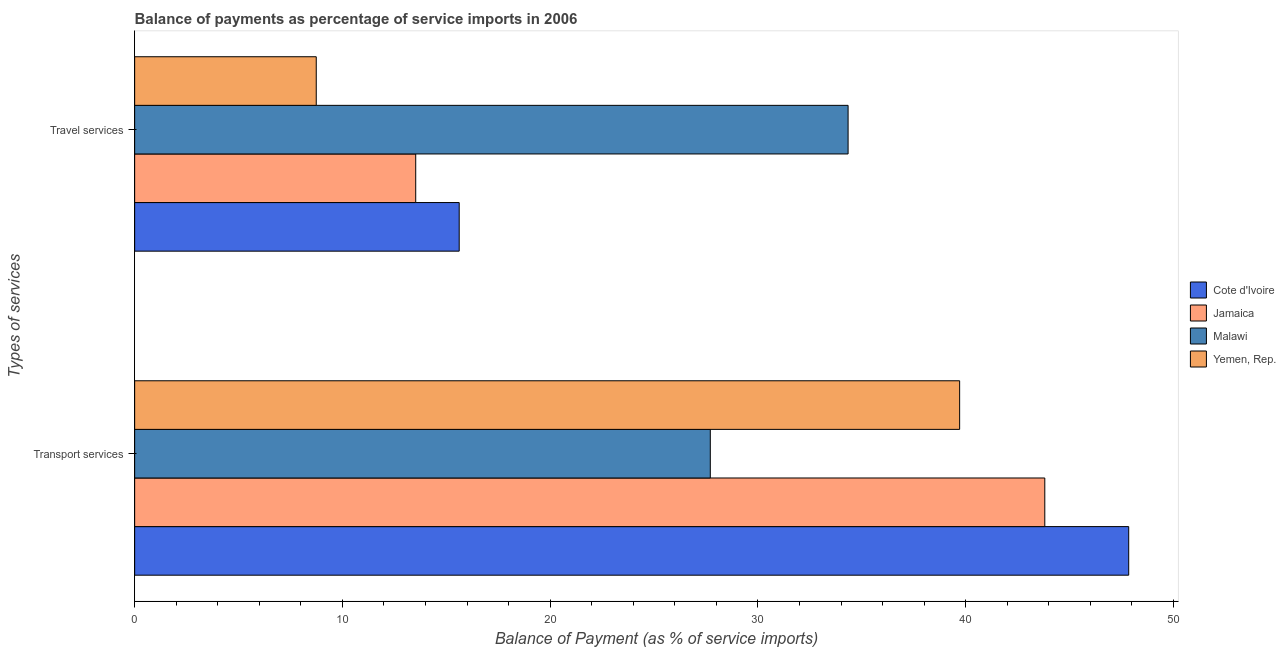How many different coloured bars are there?
Ensure brevity in your answer.  4. Are the number of bars per tick equal to the number of legend labels?
Provide a short and direct response. Yes. Are the number of bars on each tick of the Y-axis equal?
Offer a very short reply. Yes. What is the label of the 1st group of bars from the top?
Your answer should be very brief. Travel services. What is the balance of payments of travel services in Cote d'Ivoire?
Offer a very short reply. 15.62. Across all countries, what is the maximum balance of payments of transport services?
Provide a succinct answer. 47.85. Across all countries, what is the minimum balance of payments of travel services?
Give a very brief answer. 8.74. In which country was the balance of payments of transport services maximum?
Offer a very short reply. Cote d'Ivoire. In which country was the balance of payments of transport services minimum?
Offer a terse response. Malawi. What is the total balance of payments of transport services in the graph?
Offer a terse response. 159.07. What is the difference between the balance of payments of travel services in Cote d'Ivoire and that in Malawi?
Your response must be concise. -18.72. What is the difference between the balance of payments of travel services in Yemen, Rep. and the balance of payments of transport services in Malawi?
Offer a terse response. -18.97. What is the average balance of payments of transport services per country?
Make the answer very short. 39.77. What is the difference between the balance of payments of travel services and balance of payments of transport services in Yemen, Rep.?
Your response must be concise. -30.97. What is the ratio of the balance of payments of travel services in Malawi to that in Cote d'Ivoire?
Give a very brief answer. 2.2. Is the balance of payments of transport services in Cote d'Ivoire less than that in Yemen, Rep.?
Give a very brief answer. No. What does the 2nd bar from the top in Transport services represents?
Keep it short and to the point. Malawi. What does the 1st bar from the bottom in Transport services represents?
Offer a very short reply. Cote d'Ivoire. Are all the bars in the graph horizontal?
Offer a very short reply. Yes. What is the difference between two consecutive major ticks on the X-axis?
Your answer should be compact. 10. Are the values on the major ticks of X-axis written in scientific E-notation?
Offer a terse response. No. Does the graph contain grids?
Offer a terse response. No. Where does the legend appear in the graph?
Keep it short and to the point. Center right. How many legend labels are there?
Your answer should be compact. 4. How are the legend labels stacked?
Provide a short and direct response. Vertical. What is the title of the graph?
Make the answer very short. Balance of payments as percentage of service imports in 2006. Does "Belize" appear as one of the legend labels in the graph?
Give a very brief answer. No. What is the label or title of the X-axis?
Provide a succinct answer. Balance of Payment (as % of service imports). What is the label or title of the Y-axis?
Provide a succinct answer. Types of services. What is the Balance of Payment (as % of service imports) in Cote d'Ivoire in Transport services?
Offer a very short reply. 47.85. What is the Balance of Payment (as % of service imports) of Jamaica in Transport services?
Your response must be concise. 43.81. What is the Balance of Payment (as % of service imports) of Malawi in Transport services?
Your response must be concise. 27.71. What is the Balance of Payment (as % of service imports) of Yemen, Rep. in Transport services?
Give a very brief answer. 39.71. What is the Balance of Payment (as % of service imports) in Cote d'Ivoire in Travel services?
Your response must be concise. 15.62. What is the Balance of Payment (as % of service imports) of Jamaica in Travel services?
Ensure brevity in your answer.  13.53. What is the Balance of Payment (as % of service imports) in Malawi in Travel services?
Keep it short and to the point. 34.34. What is the Balance of Payment (as % of service imports) in Yemen, Rep. in Travel services?
Keep it short and to the point. 8.74. Across all Types of services, what is the maximum Balance of Payment (as % of service imports) of Cote d'Ivoire?
Offer a very short reply. 47.85. Across all Types of services, what is the maximum Balance of Payment (as % of service imports) of Jamaica?
Your response must be concise. 43.81. Across all Types of services, what is the maximum Balance of Payment (as % of service imports) of Malawi?
Offer a very short reply. 34.34. Across all Types of services, what is the maximum Balance of Payment (as % of service imports) of Yemen, Rep.?
Make the answer very short. 39.71. Across all Types of services, what is the minimum Balance of Payment (as % of service imports) of Cote d'Ivoire?
Make the answer very short. 15.62. Across all Types of services, what is the minimum Balance of Payment (as % of service imports) of Jamaica?
Offer a terse response. 13.53. Across all Types of services, what is the minimum Balance of Payment (as % of service imports) of Malawi?
Offer a terse response. 27.71. Across all Types of services, what is the minimum Balance of Payment (as % of service imports) of Yemen, Rep.?
Ensure brevity in your answer.  8.74. What is the total Balance of Payment (as % of service imports) in Cote d'Ivoire in the graph?
Offer a very short reply. 63.47. What is the total Balance of Payment (as % of service imports) in Jamaica in the graph?
Your answer should be compact. 57.34. What is the total Balance of Payment (as % of service imports) of Malawi in the graph?
Your response must be concise. 62.05. What is the total Balance of Payment (as % of service imports) in Yemen, Rep. in the graph?
Keep it short and to the point. 48.45. What is the difference between the Balance of Payment (as % of service imports) of Cote d'Ivoire in Transport services and that in Travel services?
Provide a succinct answer. 32.23. What is the difference between the Balance of Payment (as % of service imports) of Jamaica in Transport services and that in Travel services?
Give a very brief answer. 30.28. What is the difference between the Balance of Payment (as % of service imports) in Malawi in Transport services and that in Travel services?
Offer a very short reply. -6.63. What is the difference between the Balance of Payment (as % of service imports) in Yemen, Rep. in Transport services and that in Travel services?
Keep it short and to the point. 30.97. What is the difference between the Balance of Payment (as % of service imports) of Cote d'Ivoire in Transport services and the Balance of Payment (as % of service imports) of Jamaica in Travel services?
Ensure brevity in your answer.  34.32. What is the difference between the Balance of Payment (as % of service imports) in Cote d'Ivoire in Transport services and the Balance of Payment (as % of service imports) in Malawi in Travel services?
Give a very brief answer. 13.51. What is the difference between the Balance of Payment (as % of service imports) of Cote d'Ivoire in Transport services and the Balance of Payment (as % of service imports) of Yemen, Rep. in Travel services?
Offer a terse response. 39.11. What is the difference between the Balance of Payment (as % of service imports) of Jamaica in Transport services and the Balance of Payment (as % of service imports) of Malawi in Travel services?
Ensure brevity in your answer.  9.47. What is the difference between the Balance of Payment (as % of service imports) in Jamaica in Transport services and the Balance of Payment (as % of service imports) in Yemen, Rep. in Travel services?
Give a very brief answer. 35.07. What is the difference between the Balance of Payment (as % of service imports) of Malawi in Transport services and the Balance of Payment (as % of service imports) of Yemen, Rep. in Travel services?
Provide a succinct answer. 18.97. What is the average Balance of Payment (as % of service imports) in Cote d'Ivoire per Types of services?
Make the answer very short. 31.73. What is the average Balance of Payment (as % of service imports) of Jamaica per Types of services?
Offer a very short reply. 28.67. What is the average Balance of Payment (as % of service imports) in Malawi per Types of services?
Make the answer very short. 31.02. What is the average Balance of Payment (as % of service imports) of Yemen, Rep. per Types of services?
Offer a terse response. 24.23. What is the difference between the Balance of Payment (as % of service imports) of Cote d'Ivoire and Balance of Payment (as % of service imports) of Jamaica in Transport services?
Your answer should be compact. 4.04. What is the difference between the Balance of Payment (as % of service imports) in Cote d'Ivoire and Balance of Payment (as % of service imports) in Malawi in Transport services?
Provide a short and direct response. 20.14. What is the difference between the Balance of Payment (as % of service imports) of Cote d'Ivoire and Balance of Payment (as % of service imports) of Yemen, Rep. in Transport services?
Give a very brief answer. 8.14. What is the difference between the Balance of Payment (as % of service imports) of Jamaica and Balance of Payment (as % of service imports) of Malawi in Transport services?
Make the answer very short. 16.1. What is the difference between the Balance of Payment (as % of service imports) in Jamaica and Balance of Payment (as % of service imports) in Yemen, Rep. in Transport services?
Your answer should be very brief. 4.1. What is the difference between the Balance of Payment (as % of service imports) of Malawi and Balance of Payment (as % of service imports) of Yemen, Rep. in Transport services?
Your answer should be very brief. -12. What is the difference between the Balance of Payment (as % of service imports) in Cote d'Ivoire and Balance of Payment (as % of service imports) in Jamaica in Travel services?
Your answer should be compact. 2.09. What is the difference between the Balance of Payment (as % of service imports) in Cote d'Ivoire and Balance of Payment (as % of service imports) in Malawi in Travel services?
Provide a short and direct response. -18.72. What is the difference between the Balance of Payment (as % of service imports) of Cote d'Ivoire and Balance of Payment (as % of service imports) of Yemen, Rep. in Travel services?
Give a very brief answer. 6.88. What is the difference between the Balance of Payment (as % of service imports) in Jamaica and Balance of Payment (as % of service imports) in Malawi in Travel services?
Offer a terse response. -20.81. What is the difference between the Balance of Payment (as % of service imports) in Jamaica and Balance of Payment (as % of service imports) in Yemen, Rep. in Travel services?
Your response must be concise. 4.79. What is the difference between the Balance of Payment (as % of service imports) of Malawi and Balance of Payment (as % of service imports) of Yemen, Rep. in Travel services?
Your response must be concise. 25.6. What is the ratio of the Balance of Payment (as % of service imports) of Cote d'Ivoire in Transport services to that in Travel services?
Your answer should be very brief. 3.06. What is the ratio of the Balance of Payment (as % of service imports) in Jamaica in Transport services to that in Travel services?
Provide a short and direct response. 3.24. What is the ratio of the Balance of Payment (as % of service imports) of Malawi in Transport services to that in Travel services?
Provide a short and direct response. 0.81. What is the ratio of the Balance of Payment (as % of service imports) of Yemen, Rep. in Transport services to that in Travel services?
Make the answer very short. 4.54. What is the difference between the highest and the second highest Balance of Payment (as % of service imports) in Cote d'Ivoire?
Offer a terse response. 32.23. What is the difference between the highest and the second highest Balance of Payment (as % of service imports) of Jamaica?
Offer a terse response. 30.28. What is the difference between the highest and the second highest Balance of Payment (as % of service imports) in Malawi?
Your answer should be compact. 6.63. What is the difference between the highest and the second highest Balance of Payment (as % of service imports) of Yemen, Rep.?
Ensure brevity in your answer.  30.97. What is the difference between the highest and the lowest Balance of Payment (as % of service imports) of Cote d'Ivoire?
Your answer should be compact. 32.23. What is the difference between the highest and the lowest Balance of Payment (as % of service imports) in Jamaica?
Your answer should be compact. 30.28. What is the difference between the highest and the lowest Balance of Payment (as % of service imports) of Malawi?
Offer a very short reply. 6.63. What is the difference between the highest and the lowest Balance of Payment (as % of service imports) in Yemen, Rep.?
Provide a succinct answer. 30.97. 